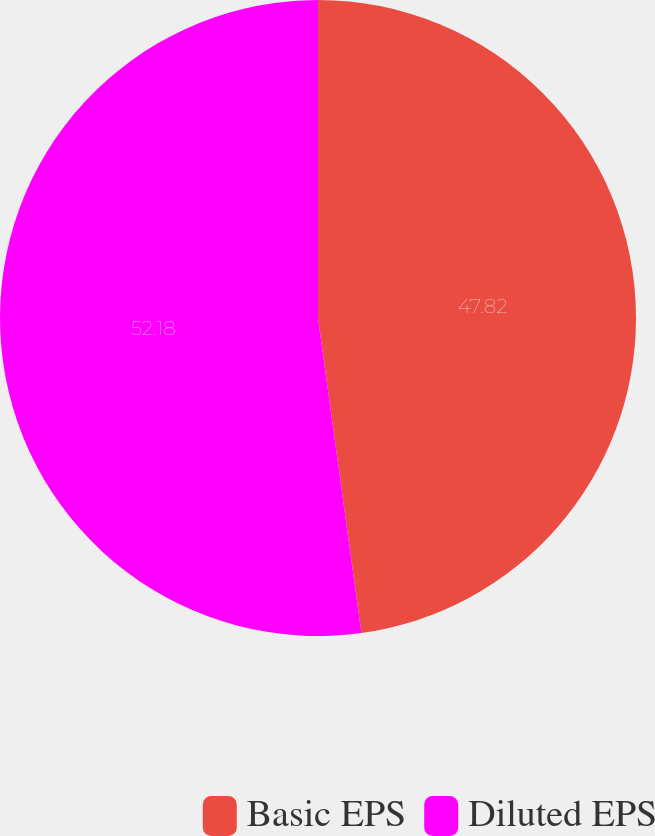Convert chart. <chart><loc_0><loc_0><loc_500><loc_500><pie_chart><fcel>Basic EPS<fcel>Diluted EPS<nl><fcel>47.82%<fcel>52.18%<nl></chart> 